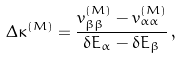<formula> <loc_0><loc_0><loc_500><loc_500>\Delta \kappa ^ { ( M ) } = \frac { v ^ { ( M ) } _ { \beta \beta } - v ^ { ( M ) } _ { \alpha \alpha } } { \delta E _ { \alpha } - \delta E _ { \beta } } \, ,</formula> 